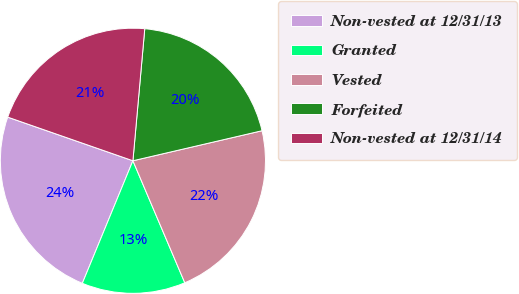Convert chart. <chart><loc_0><loc_0><loc_500><loc_500><pie_chart><fcel>Non-vested at 12/31/13<fcel>Granted<fcel>Vested<fcel>Forfeited<fcel>Non-vested at 12/31/14<nl><fcel>24.11%<fcel>12.63%<fcel>22.24%<fcel>19.94%<fcel>21.09%<nl></chart> 